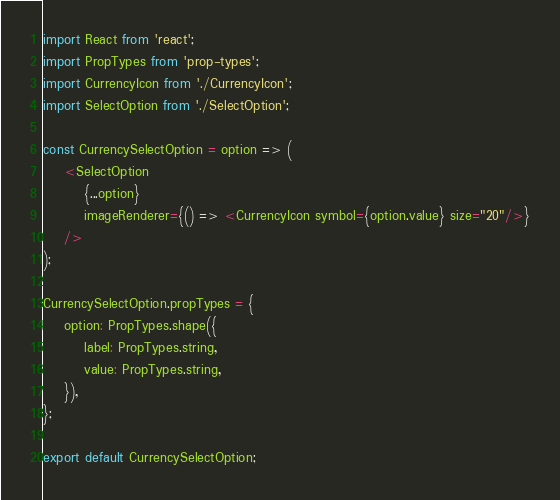<code> <loc_0><loc_0><loc_500><loc_500><_JavaScript_>import React from 'react';
import PropTypes from 'prop-types';
import CurrencyIcon from './CurrencyIcon';
import SelectOption from './SelectOption';

const CurrencySelectOption = option => (
	<SelectOption
		{...option}
		imageRenderer={() => <CurrencyIcon symbol={option.value} size="20"/>}
	/>
);

CurrencySelectOption.propTypes = {
	option: PropTypes.shape({
		label: PropTypes.string,
		value: PropTypes.string,
	}),
};

export default CurrencySelectOption;
</code> 